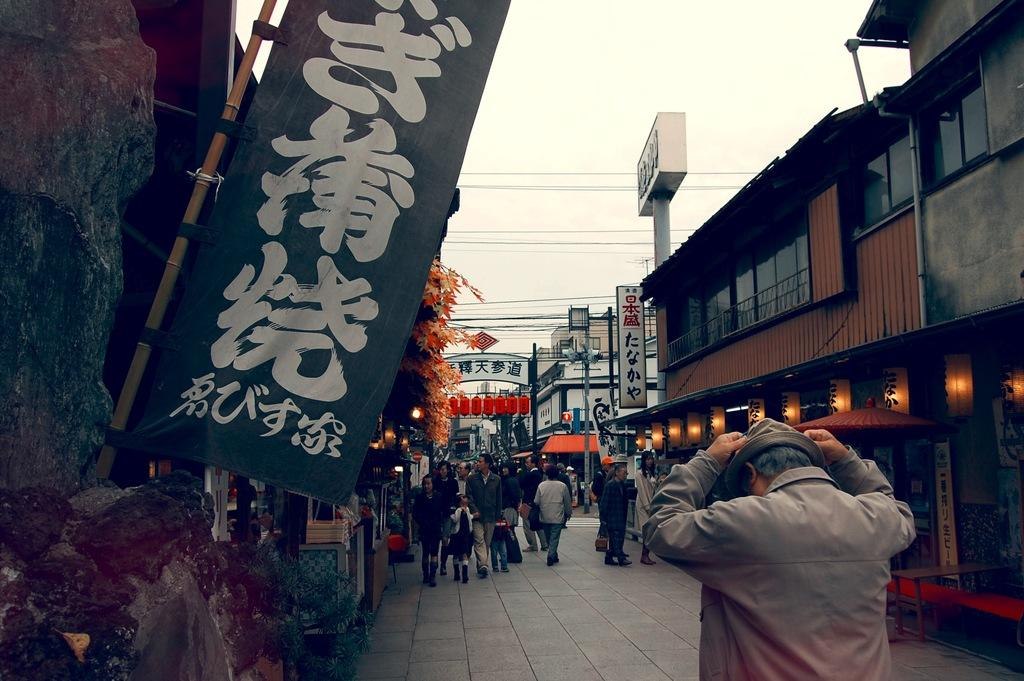Who or what can be seen in the image? There are people in the image. Where is the flag located in the image? The flag is on the left side of the image. What can be seen in the background of the image? There are boards, buildings, trees, wires, and the sky visible in the background of the image. What type of stove is being used to prepare breakfast in the image? There is no stove or breakfast present in the image. 